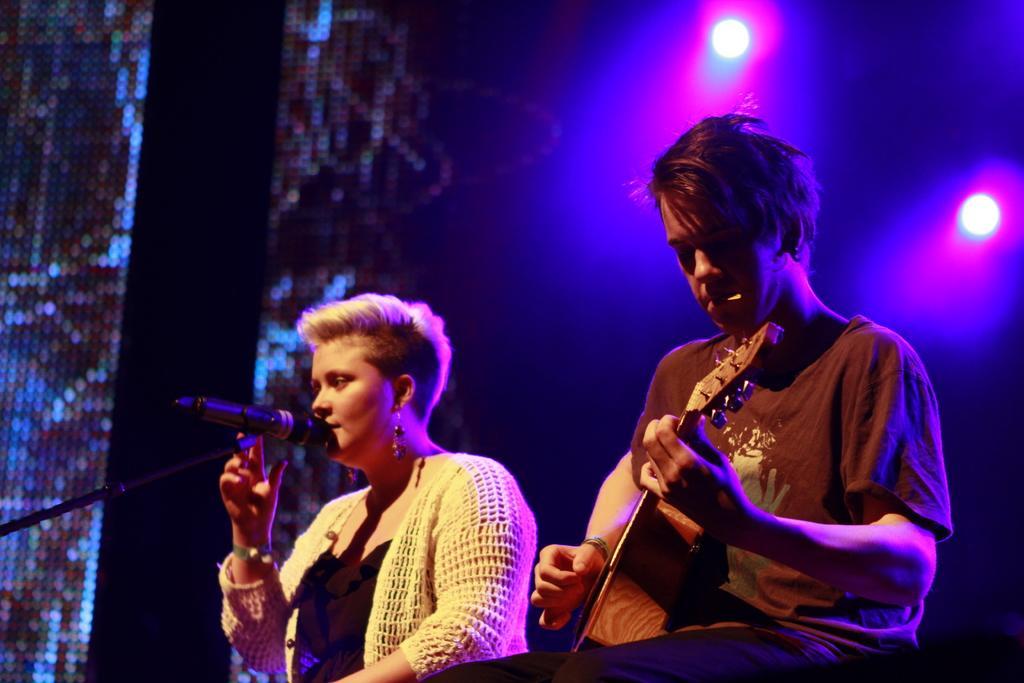Please provide a concise description of this image. In this image we can see two persons. On the right side the man is playing a guitar and on the left side the woman is singing in the mic at the background we can see a light. 